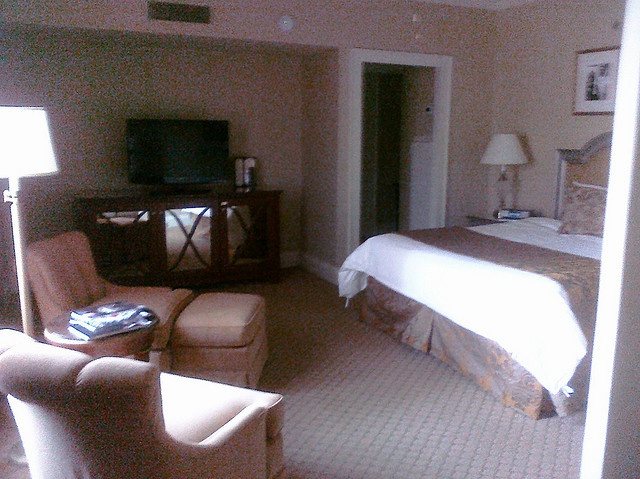Describe the objects in this image and their specific colors. I can see bed in gray, white, and darkgray tones, couch in gray, white, maroon, and black tones, chair in gray, white, maroon, and black tones, chair in gray, brown, and maroon tones, and tv in gray, black, maroon, and navy tones in this image. 